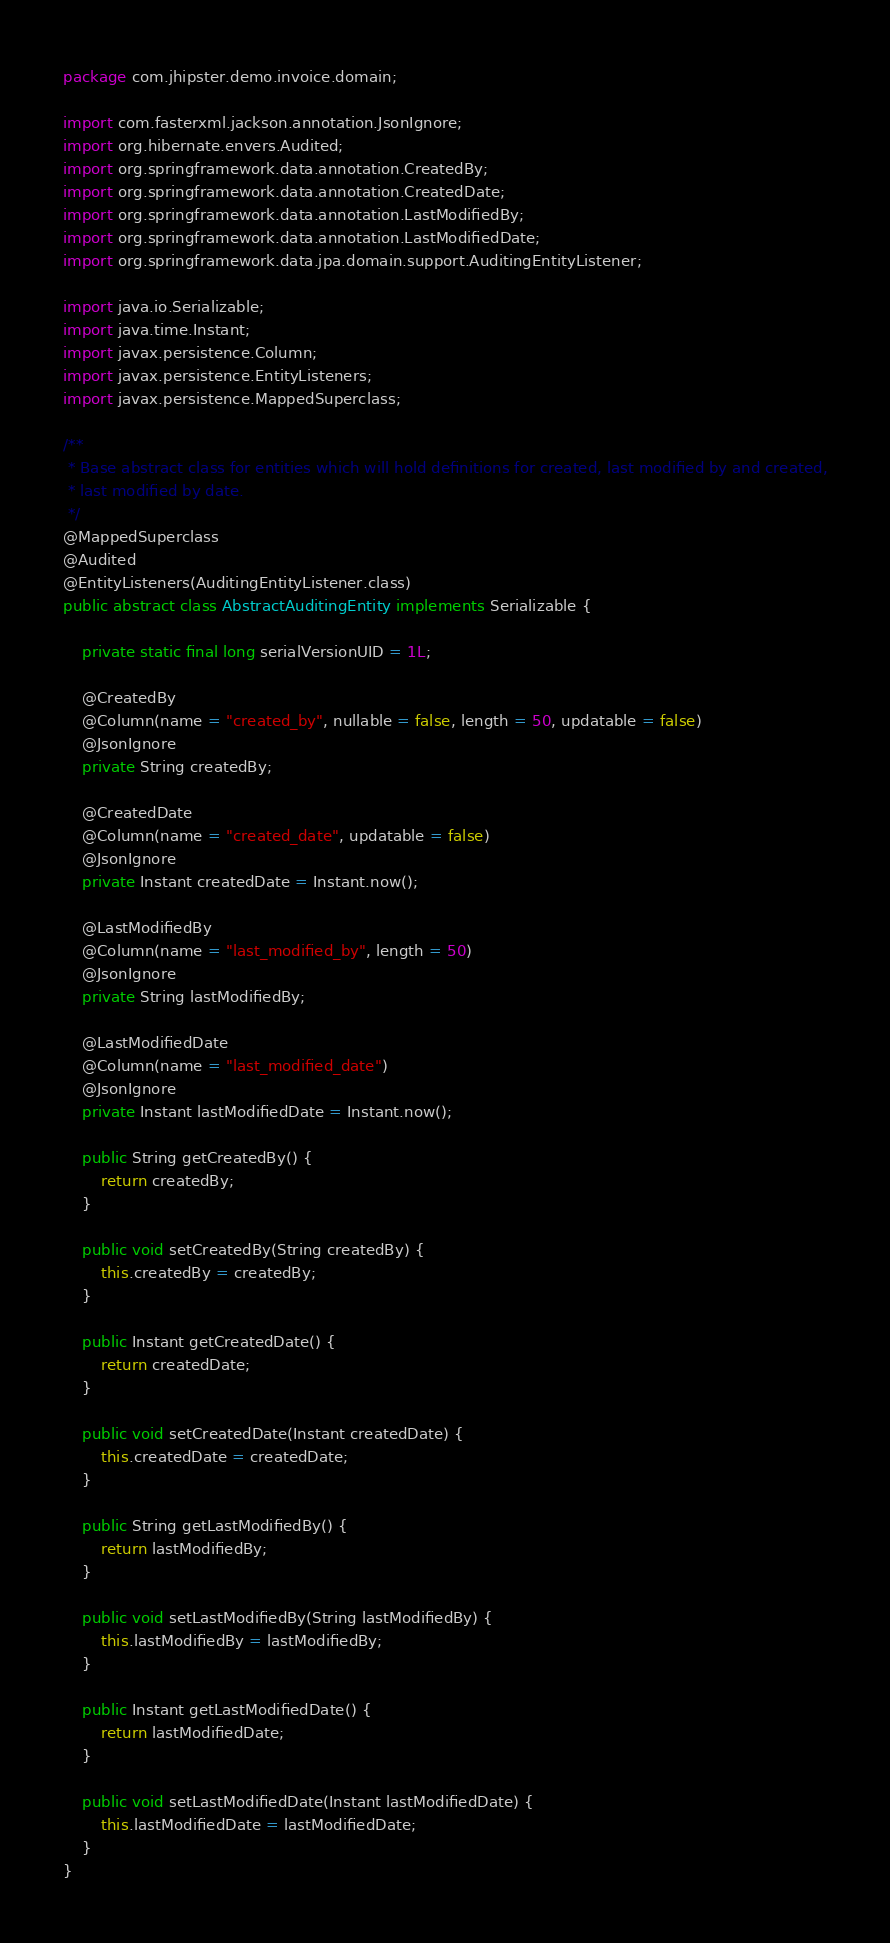<code> <loc_0><loc_0><loc_500><loc_500><_Java_>package com.jhipster.demo.invoice.domain;

import com.fasterxml.jackson.annotation.JsonIgnore;
import org.hibernate.envers.Audited;
import org.springframework.data.annotation.CreatedBy;
import org.springframework.data.annotation.CreatedDate;
import org.springframework.data.annotation.LastModifiedBy;
import org.springframework.data.annotation.LastModifiedDate;
import org.springframework.data.jpa.domain.support.AuditingEntityListener;

import java.io.Serializable;
import java.time.Instant;
import javax.persistence.Column;
import javax.persistence.EntityListeners;
import javax.persistence.MappedSuperclass;

/**
 * Base abstract class for entities which will hold definitions for created, last modified by and created,
 * last modified by date.
 */
@MappedSuperclass
@Audited
@EntityListeners(AuditingEntityListener.class)
public abstract class AbstractAuditingEntity implements Serializable {

    private static final long serialVersionUID = 1L;

    @CreatedBy
    @Column(name = "created_by", nullable = false, length = 50, updatable = false)
    @JsonIgnore
    private String createdBy;

    @CreatedDate
    @Column(name = "created_date", updatable = false)
    @JsonIgnore
    private Instant createdDate = Instant.now();

    @LastModifiedBy
    @Column(name = "last_modified_by", length = 50)
    @JsonIgnore
    private String lastModifiedBy;

    @LastModifiedDate
    @Column(name = "last_modified_date")
    @JsonIgnore
    private Instant lastModifiedDate = Instant.now();

    public String getCreatedBy() {
        return createdBy;
    }

    public void setCreatedBy(String createdBy) {
        this.createdBy = createdBy;
    }

    public Instant getCreatedDate() {
        return createdDate;
    }

    public void setCreatedDate(Instant createdDate) {
        this.createdDate = createdDate;
    }

    public String getLastModifiedBy() {
        return lastModifiedBy;
    }

    public void setLastModifiedBy(String lastModifiedBy) {
        this.lastModifiedBy = lastModifiedBy;
    }

    public Instant getLastModifiedDate() {
        return lastModifiedDate;
    }

    public void setLastModifiedDate(Instant lastModifiedDate) {
        this.lastModifiedDate = lastModifiedDate;
    }
}
</code> 